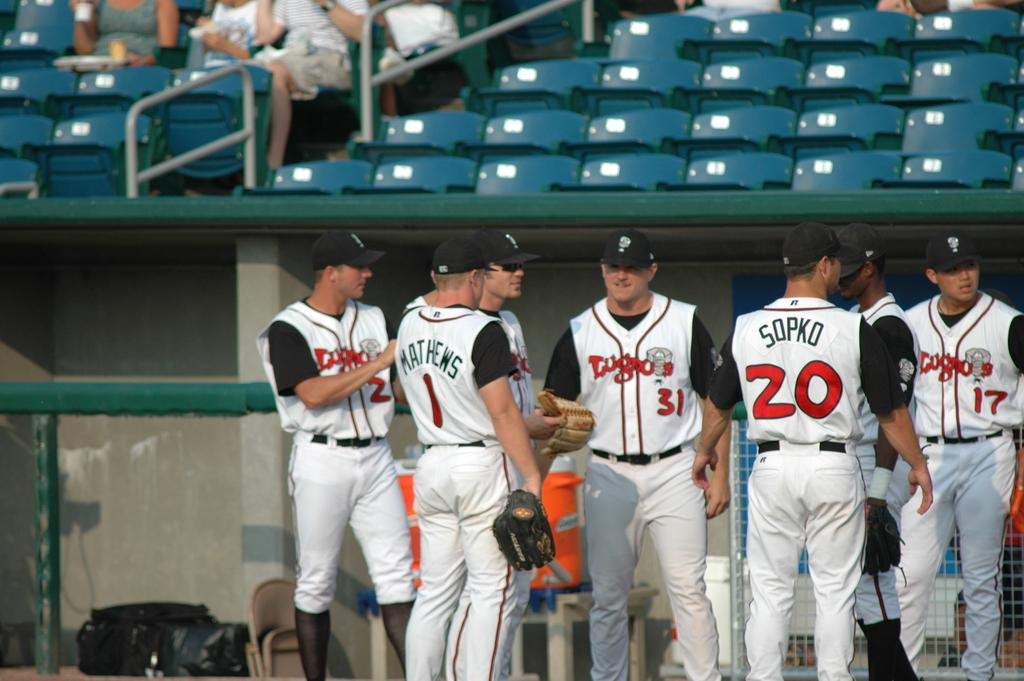<image>
Present a compact description of the photo's key features. Baseball players converge with their teammates including those wearing numbers 1 and 20. 